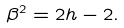<formula> <loc_0><loc_0><loc_500><loc_500>\beta ^ { 2 } = 2 h - 2 .</formula> 